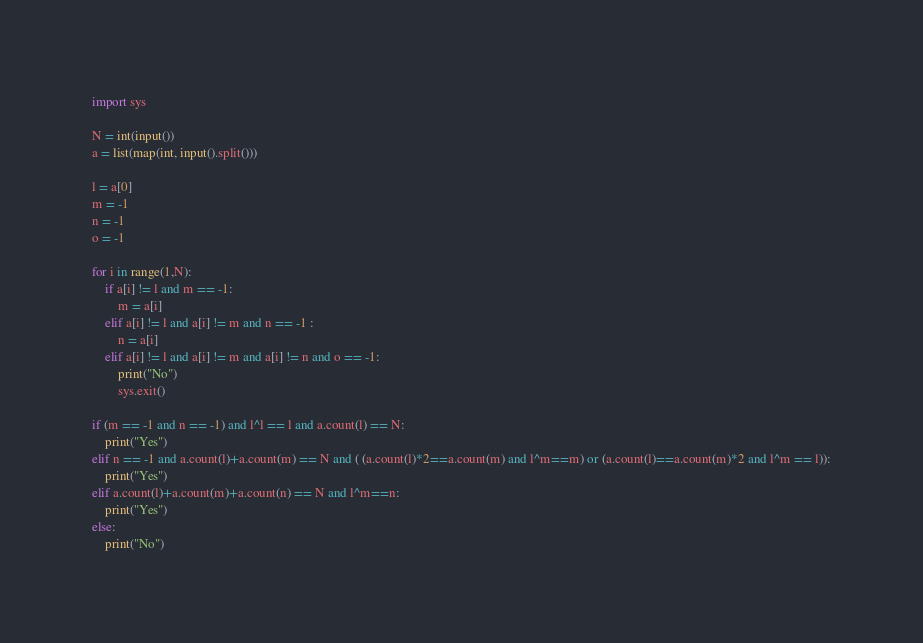<code> <loc_0><loc_0><loc_500><loc_500><_Python_>import sys

N = int(input())
a = list(map(int, input().split()))

l = a[0]
m = -1
n = -1
o = -1

for i in range(1,N):
    if a[i] != l and m == -1:
        m = a[i]
    elif a[i] != l and a[i] != m and n == -1 :
        n = a[i]
    elif a[i] != l and a[i] != m and a[i] != n and o == -1:
        print("No")
        sys.exit()

if (m == -1 and n == -1) and l^l == l and a.count(l) == N:
    print("Yes")
elif n == -1 and a.count(l)+a.count(m) == N and ( (a.count(l)*2==a.count(m) and l^m==m) or (a.count(l)==a.count(m)*2 and l^m == l)):
    print("Yes")
elif a.count(l)+a.count(m)+a.count(n) == N and l^m==n:
    print("Yes")
else:
    print("No")</code> 